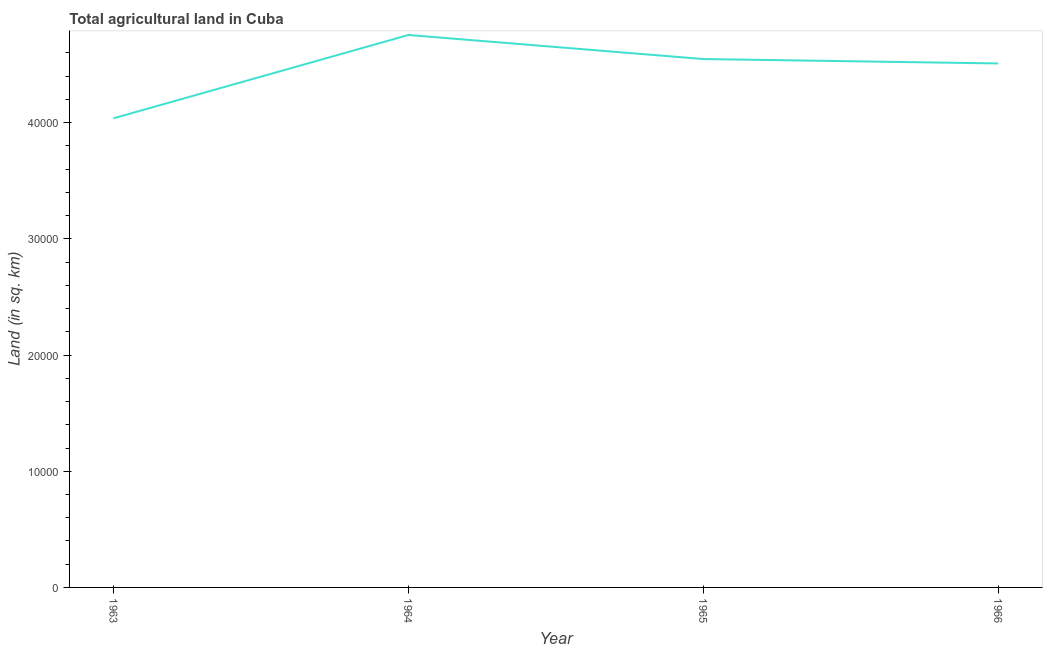What is the agricultural land in 1966?
Your answer should be very brief. 4.51e+04. Across all years, what is the maximum agricultural land?
Provide a succinct answer. 4.76e+04. Across all years, what is the minimum agricultural land?
Provide a short and direct response. 4.04e+04. In which year was the agricultural land maximum?
Your answer should be very brief. 1964. What is the sum of the agricultural land?
Ensure brevity in your answer.  1.79e+05. What is the difference between the agricultural land in 1963 and 1964?
Provide a succinct answer. -7170. What is the average agricultural land per year?
Provide a succinct answer. 4.46e+04. What is the median agricultural land?
Provide a short and direct response. 4.53e+04. Do a majority of the years between 1966 and 1964 (inclusive) have agricultural land greater than 40000 sq. km?
Offer a terse response. No. What is the ratio of the agricultural land in 1963 to that in 1964?
Your response must be concise. 0.85. What is the difference between the highest and the second highest agricultural land?
Your response must be concise. 2070. Is the sum of the agricultural land in 1964 and 1966 greater than the maximum agricultural land across all years?
Make the answer very short. Yes. What is the difference between the highest and the lowest agricultural land?
Provide a succinct answer. 7170. Does the agricultural land monotonically increase over the years?
Your answer should be very brief. No. What is the difference between two consecutive major ticks on the Y-axis?
Keep it short and to the point. 10000. Are the values on the major ticks of Y-axis written in scientific E-notation?
Keep it short and to the point. No. What is the title of the graph?
Your response must be concise. Total agricultural land in Cuba. What is the label or title of the X-axis?
Ensure brevity in your answer.  Year. What is the label or title of the Y-axis?
Make the answer very short. Land (in sq. km). What is the Land (in sq. km) in 1963?
Provide a succinct answer. 4.04e+04. What is the Land (in sq. km) in 1964?
Provide a succinct answer. 4.76e+04. What is the Land (in sq. km) of 1965?
Provide a succinct answer. 4.55e+04. What is the Land (in sq. km) of 1966?
Make the answer very short. 4.51e+04. What is the difference between the Land (in sq. km) in 1963 and 1964?
Make the answer very short. -7170. What is the difference between the Land (in sq. km) in 1963 and 1965?
Keep it short and to the point. -5100. What is the difference between the Land (in sq. km) in 1963 and 1966?
Make the answer very short. -4720. What is the difference between the Land (in sq. km) in 1964 and 1965?
Offer a terse response. 2070. What is the difference between the Land (in sq. km) in 1964 and 1966?
Your answer should be very brief. 2450. What is the difference between the Land (in sq. km) in 1965 and 1966?
Keep it short and to the point. 380. What is the ratio of the Land (in sq. km) in 1963 to that in 1964?
Your response must be concise. 0.85. What is the ratio of the Land (in sq. km) in 1963 to that in 1965?
Keep it short and to the point. 0.89. What is the ratio of the Land (in sq. km) in 1963 to that in 1966?
Your answer should be very brief. 0.9. What is the ratio of the Land (in sq. km) in 1964 to that in 1965?
Offer a terse response. 1.05. What is the ratio of the Land (in sq. km) in 1964 to that in 1966?
Your response must be concise. 1.05. 